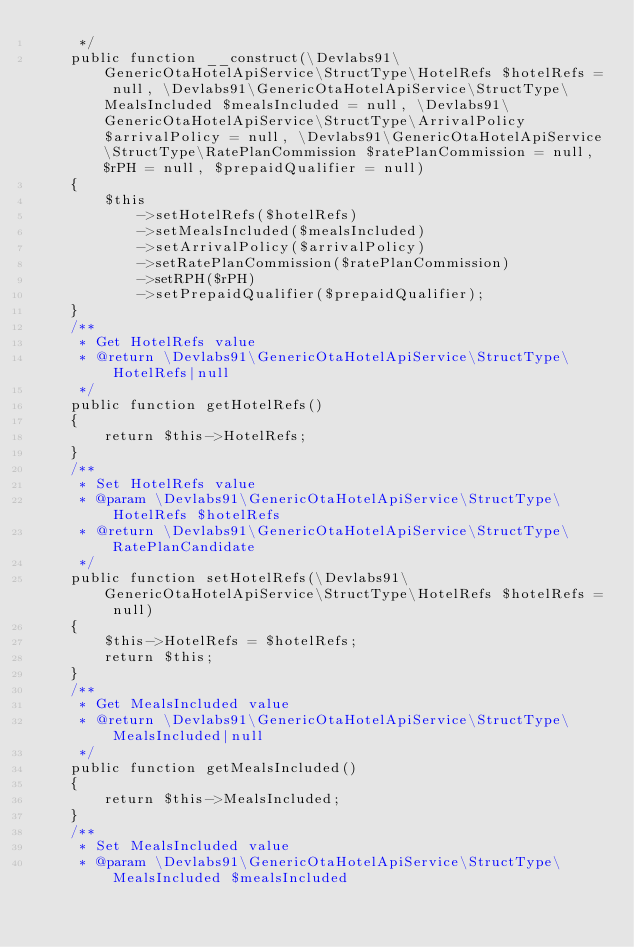Convert code to text. <code><loc_0><loc_0><loc_500><loc_500><_PHP_>     */
    public function __construct(\Devlabs91\GenericOtaHotelApiService\StructType\HotelRefs $hotelRefs = null, \Devlabs91\GenericOtaHotelApiService\StructType\MealsIncluded $mealsIncluded = null, \Devlabs91\GenericOtaHotelApiService\StructType\ArrivalPolicy $arrivalPolicy = null, \Devlabs91\GenericOtaHotelApiService\StructType\RatePlanCommission $ratePlanCommission = null, $rPH = null, $prepaidQualifier = null)
    {
        $this
            ->setHotelRefs($hotelRefs)
            ->setMealsIncluded($mealsIncluded)
            ->setArrivalPolicy($arrivalPolicy)
            ->setRatePlanCommission($ratePlanCommission)
            ->setRPH($rPH)
            ->setPrepaidQualifier($prepaidQualifier);
    }
    /**
     * Get HotelRefs value
     * @return \Devlabs91\GenericOtaHotelApiService\StructType\HotelRefs|null
     */
    public function getHotelRefs()
    {
        return $this->HotelRefs;
    }
    /**
     * Set HotelRefs value
     * @param \Devlabs91\GenericOtaHotelApiService\StructType\HotelRefs $hotelRefs
     * @return \Devlabs91\GenericOtaHotelApiService\StructType\RatePlanCandidate
     */
    public function setHotelRefs(\Devlabs91\GenericOtaHotelApiService\StructType\HotelRefs $hotelRefs = null)
    {
        $this->HotelRefs = $hotelRefs;
        return $this;
    }
    /**
     * Get MealsIncluded value
     * @return \Devlabs91\GenericOtaHotelApiService\StructType\MealsIncluded|null
     */
    public function getMealsIncluded()
    {
        return $this->MealsIncluded;
    }
    /**
     * Set MealsIncluded value
     * @param \Devlabs91\GenericOtaHotelApiService\StructType\MealsIncluded $mealsIncluded</code> 